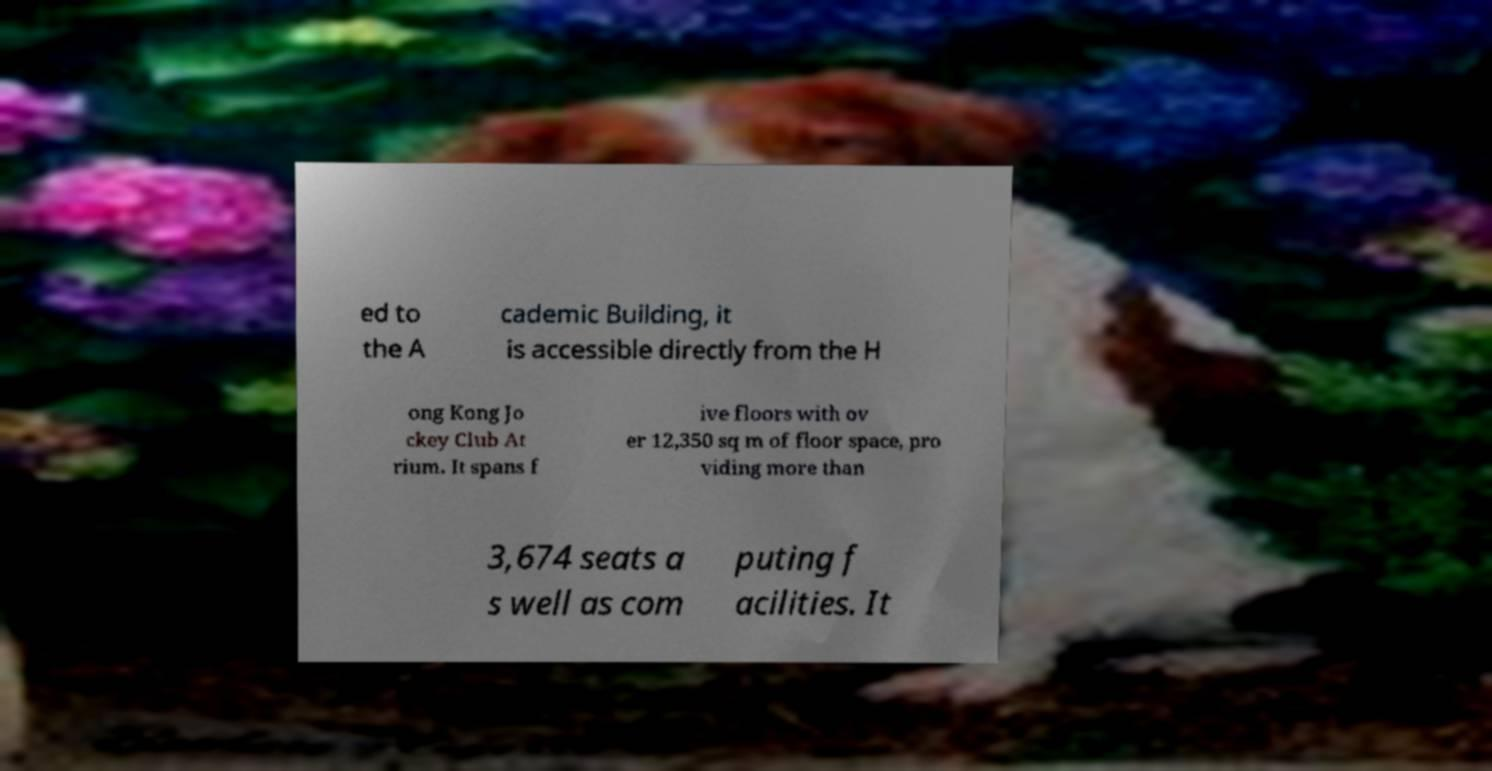There's text embedded in this image that I need extracted. Can you transcribe it verbatim? ed to the A cademic Building, it is accessible directly from the H ong Kong Jo ckey Club At rium. It spans f ive floors with ov er 12,350 sq m of floor space, pro viding more than 3,674 seats a s well as com puting f acilities. It 